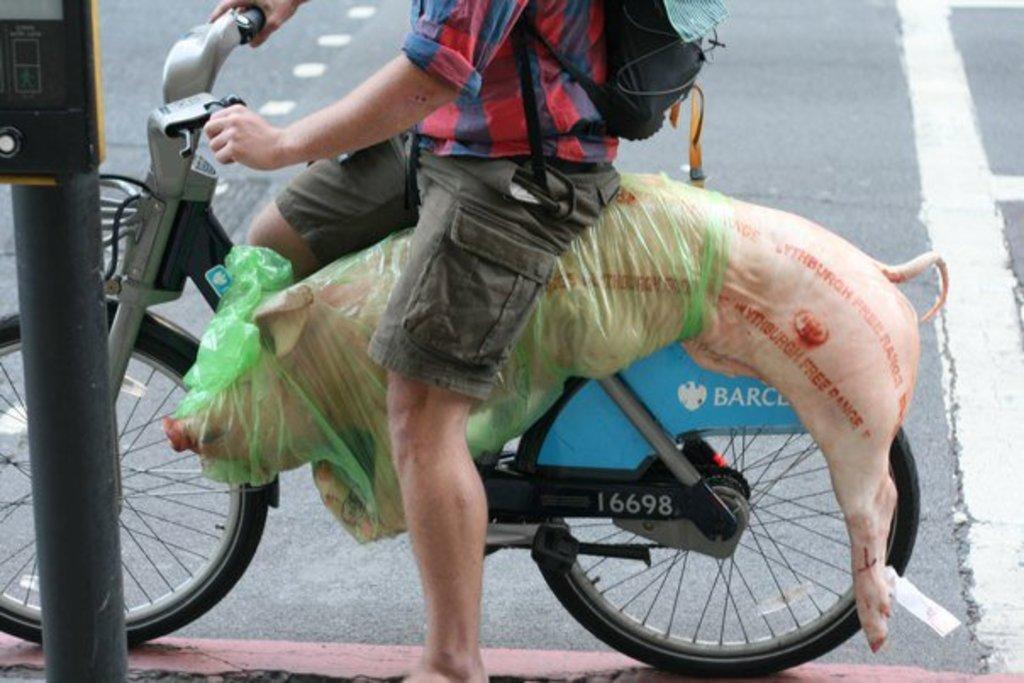In one or two sentences, can you explain what this image depicts? In this image a person riding a bicycle carrying a pig on his bicycle. 